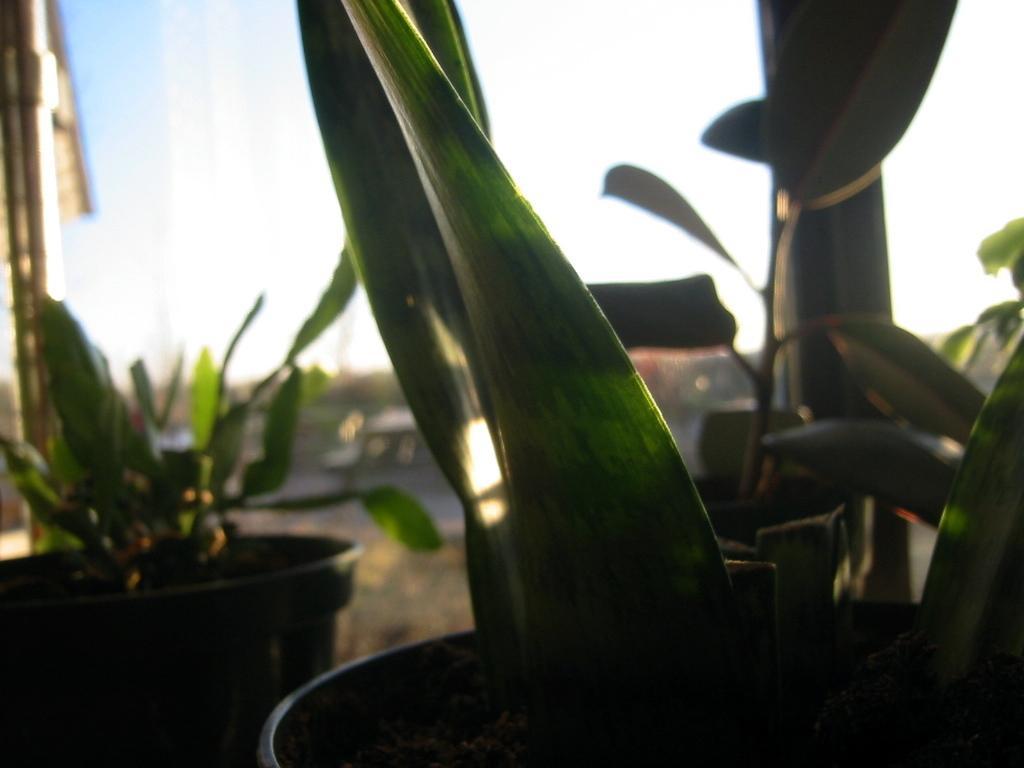In one or two sentences, can you explain what this image depicts? In the front of the image there are plants with pots. In the background of the image it is blurry.  